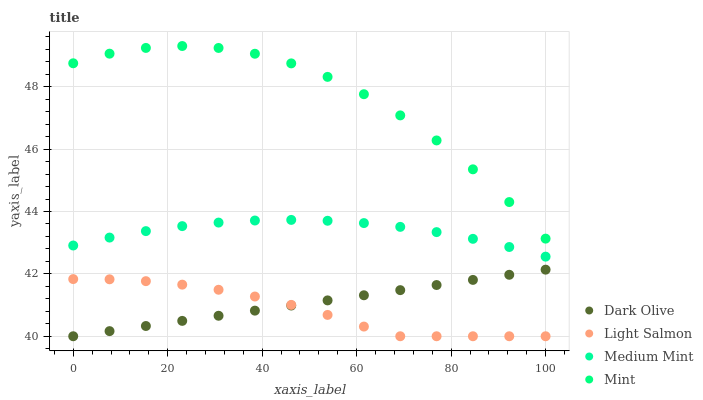Does Light Salmon have the minimum area under the curve?
Answer yes or no. Yes. Does Mint have the maximum area under the curve?
Answer yes or no. Yes. Does Dark Olive have the minimum area under the curve?
Answer yes or no. No. Does Dark Olive have the maximum area under the curve?
Answer yes or no. No. Is Dark Olive the smoothest?
Answer yes or no. Yes. Is Mint the roughest?
Answer yes or no. Yes. Is Light Salmon the smoothest?
Answer yes or no. No. Is Light Salmon the roughest?
Answer yes or no. No. Does Light Salmon have the lowest value?
Answer yes or no. Yes. Does Mint have the lowest value?
Answer yes or no. No. Does Mint have the highest value?
Answer yes or no. Yes. Does Dark Olive have the highest value?
Answer yes or no. No. Is Dark Olive less than Medium Mint?
Answer yes or no. Yes. Is Mint greater than Light Salmon?
Answer yes or no. Yes. Does Light Salmon intersect Dark Olive?
Answer yes or no. Yes. Is Light Salmon less than Dark Olive?
Answer yes or no. No. Is Light Salmon greater than Dark Olive?
Answer yes or no. No. Does Dark Olive intersect Medium Mint?
Answer yes or no. No. 